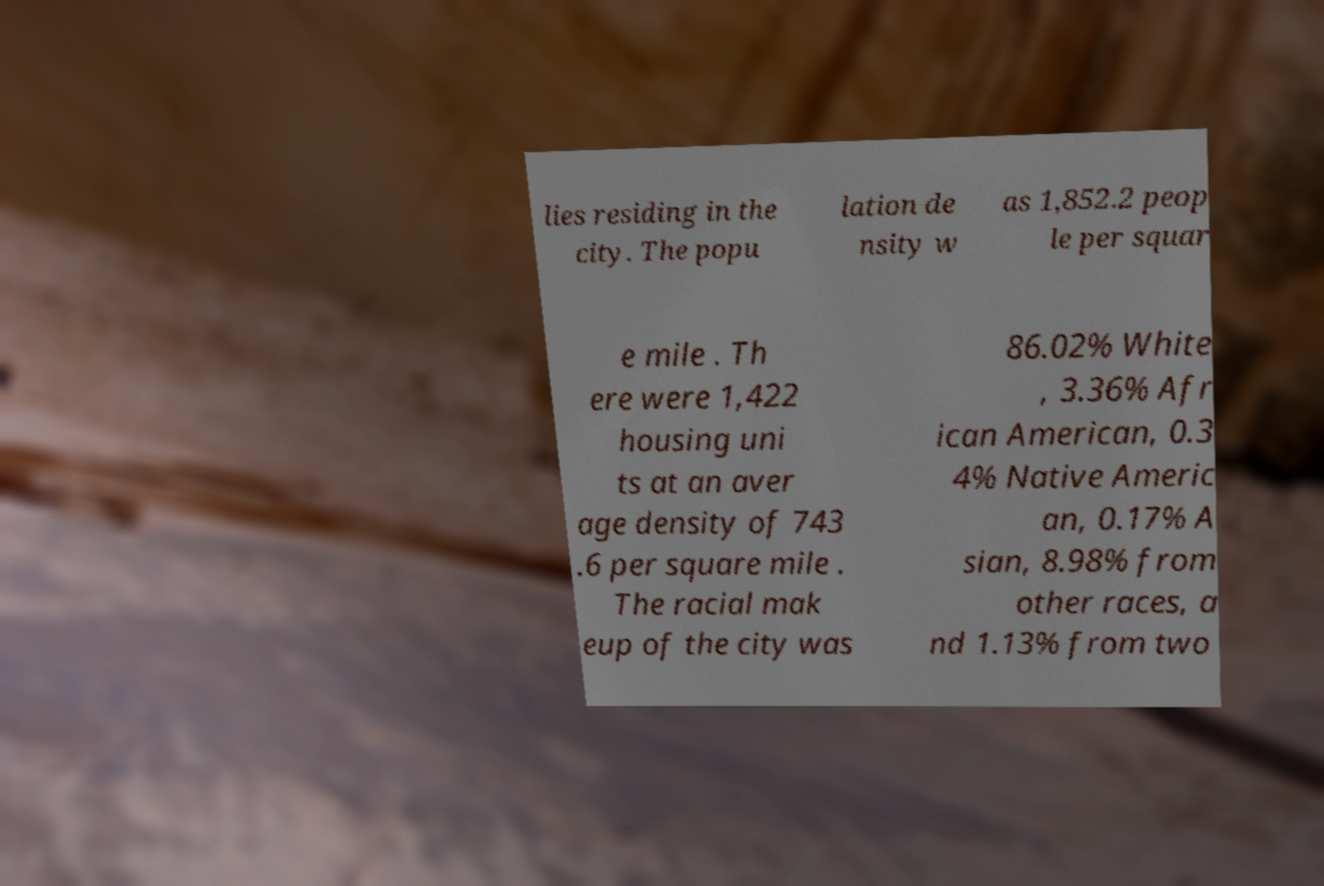Could you assist in decoding the text presented in this image and type it out clearly? lies residing in the city. The popu lation de nsity w as 1,852.2 peop le per squar e mile . Th ere were 1,422 housing uni ts at an aver age density of 743 .6 per square mile . The racial mak eup of the city was 86.02% White , 3.36% Afr ican American, 0.3 4% Native Americ an, 0.17% A sian, 8.98% from other races, a nd 1.13% from two 